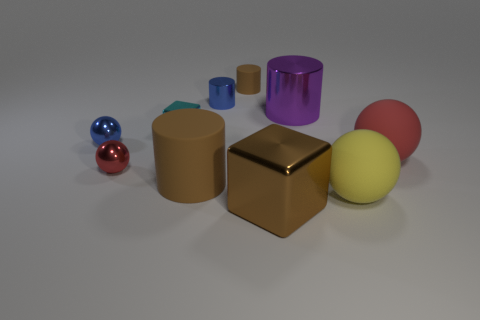Does the red ball that is left of the small brown thing have the same material as the large brown object to the left of the big brown metallic cube?
Your response must be concise. No. Are there the same number of yellow rubber objects behind the cyan cube and small brown cylinders that are behind the tiny blue metal sphere?
Your response must be concise. No. The small block that is the same material as the small red thing is what color?
Your response must be concise. Cyan. What number of tiny cubes are made of the same material as the yellow object?
Your answer should be compact. 0. Does the large cylinder that is to the left of the purple thing have the same color as the big metallic cube?
Your answer should be compact. Yes. What number of tiny blue shiny objects are the same shape as the yellow matte thing?
Your answer should be compact. 1. Is the number of yellow balls that are left of the small cyan metallic object the same as the number of small green metallic cylinders?
Give a very brief answer. Yes. What is the color of the matte cylinder that is the same size as the blue shiny cylinder?
Provide a short and direct response. Brown. Is there a small yellow object of the same shape as the big yellow object?
Offer a very short reply. No. There is a block that is in front of the rubber cylinder that is in front of the large cylinder behind the small red shiny ball; what is its material?
Provide a short and direct response. Metal. 